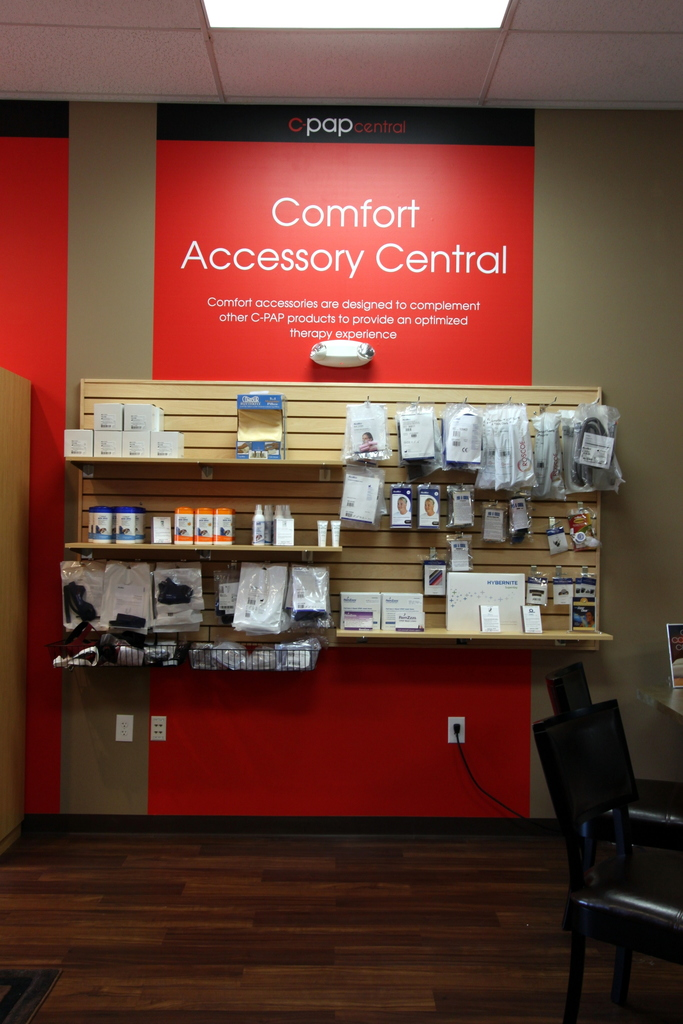Provide a one-sentence caption for the provided image. The image showcases an orderly display of CPAP therapy comfort accessories at 'CPAP Central', designed to enhance the therapeutic experience for users. 